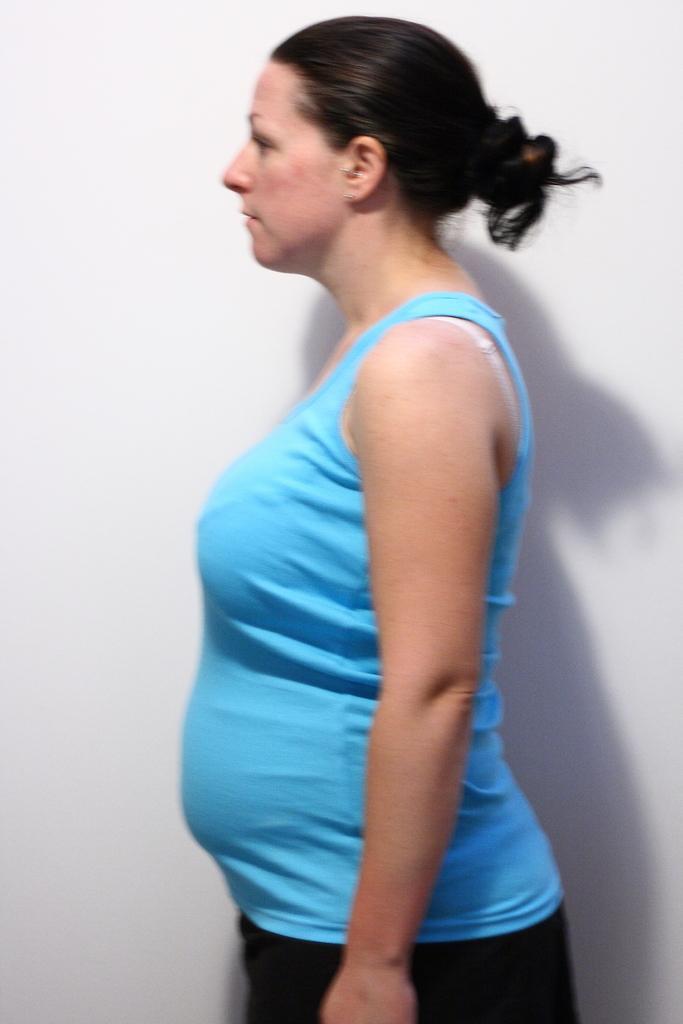Describe this image in one or two sentences. In this image in front there is a person. Behind her there is a wall. 